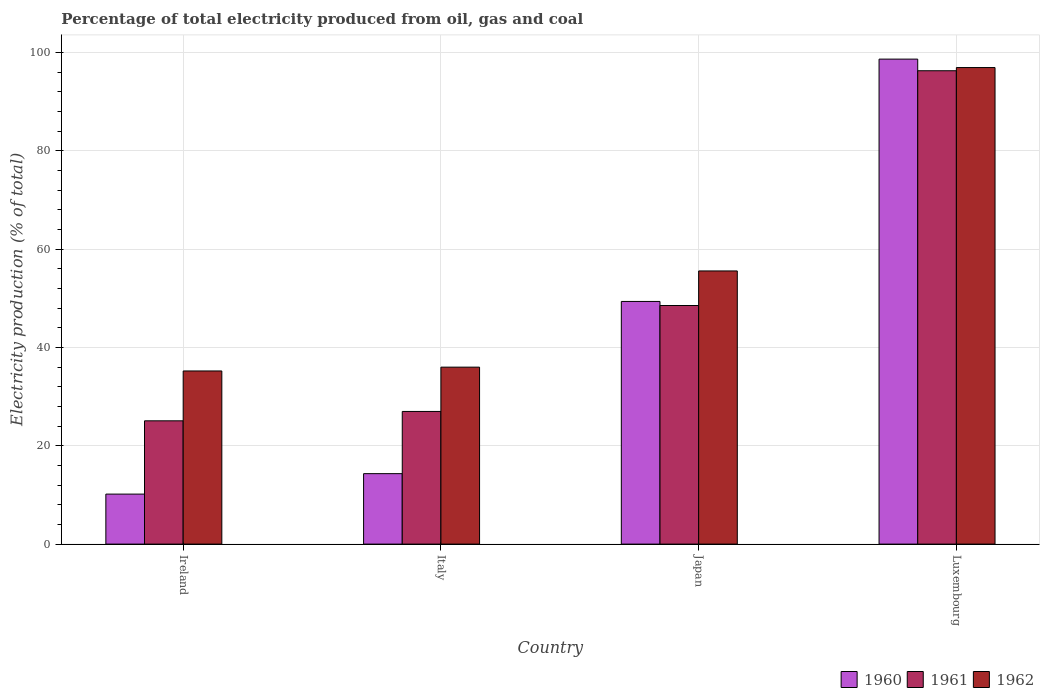How many groups of bars are there?
Offer a terse response. 4. Are the number of bars per tick equal to the number of legend labels?
Your answer should be very brief. Yes. How many bars are there on the 4th tick from the left?
Offer a terse response. 3. How many bars are there on the 1st tick from the right?
Keep it short and to the point. 3. What is the electricity production in in 1961 in Ireland?
Provide a succinct answer. 25.07. Across all countries, what is the maximum electricity production in in 1961?
Provide a succinct answer. 96.27. Across all countries, what is the minimum electricity production in in 1960?
Your answer should be very brief. 10.17. In which country was the electricity production in in 1962 maximum?
Ensure brevity in your answer.  Luxembourg. In which country was the electricity production in in 1962 minimum?
Ensure brevity in your answer.  Ireland. What is the total electricity production in in 1960 in the graph?
Provide a succinct answer. 172.48. What is the difference between the electricity production in in 1961 in Italy and that in Japan?
Provide a short and direct response. -21.55. What is the difference between the electricity production in in 1961 in Luxembourg and the electricity production in in 1960 in Ireland?
Ensure brevity in your answer.  86.1. What is the average electricity production in in 1962 per country?
Your response must be concise. 55.92. What is the difference between the electricity production in of/in 1960 and electricity production in of/in 1962 in Luxembourg?
Provide a succinct answer. 1.72. What is the ratio of the electricity production in in 1961 in Ireland to that in Italy?
Your response must be concise. 0.93. Is the difference between the electricity production in in 1960 in Japan and Luxembourg greater than the difference between the electricity production in in 1962 in Japan and Luxembourg?
Give a very brief answer. No. What is the difference between the highest and the second highest electricity production in in 1961?
Ensure brevity in your answer.  47.75. What is the difference between the highest and the lowest electricity production in in 1960?
Keep it short and to the point. 88.47. What does the 2nd bar from the right in Japan represents?
Provide a succinct answer. 1961. Is it the case that in every country, the sum of the electricity production in in 1962 and electricity production in in 1960 is greater than the electricity production in in 1961?
Provide a succinct answer. Yes. How many countries are there in the graph?
Ensure brevity in your answer.  4. Does the graph contain grids?
Provide a short and direct response. Yes. How many legend labels are there?
Ensure brevity in your answer.  3. What is the title of the graph?
Your response must be concise. Percentage of total electricity produced from oil, gas and coal. What is the label or title of the Y-axis?
Your response must be concise. Electricity production (% of total). What is the Electricity production (% of total) in 1960 in Ireland?
Your answer should be very brief. 10.17. What is the Electricity production (% of total) in 1961 in Ireland?
Your answer should be very brief. 25.07. What is the Electricity production (% of total) of 1962 in Ireland?
Offer a terse response. 35.21. What is the Electricity production (% of total) of 1960 in Italy?
Keep it short and to the point. 14.33. What is the Electricity production (% of total) of 1961 in Italy?
Keep it short and to the point. 26.98. What is the Electricity production (% of total) in 1962 in Italy?
Keep it short and to the point. 35.99. What is the Electricity production (% of total) of 1960 in Japan?
Make the answer very short. 49.35. What is the Electricity production (% of total) of 1961 in Japan?
Make the answer very short. 48.52. What is the Electricity production (% of total) of 1962 in Japan?
Provide a short and direct response. 55.56. What is the Electricity production (% of total) in 1960 in Luxembourg?
Provide a short and direct response. 98.63. What is the Electricity production (% of total) of 1961 in Luxembourg?
Your answer should be very brief. 96.27. What is the Electricity production (% of total) of 1962 in Luxembourg?
Offer a very short reply. 96.92. Across all countries, what is the maximum Electricity production (% of total) of 1960?
Keep it short and to the point. 98.63. Across all countries, what is the maximum Electricity production (% of total) in 1961?
Your response must be concise. 96.27. Across all countries, what is the maximum Electricity production (% of total) of 1962?
Provide a succinct answer. 96.92. Across all countries, what is the minimum Electricity production (% of total) of 1960?
Offer a terse response. 10.17. Across all countries, what is the minimum Electricity production (% of total) of 1961?
Keep it short and to the point. 25.07. Across all countries, what is the minimum Electricity production (% of total) in 1962?
Ensure brevity in your answer.  35.21. What is the total Electricity production (% of total) in 1960 in the graph?
Give a very brief answer. 172.48. What is the total Electricity production (% of total) in 1961 in the graph?
Ensure brevity in your answer.  196.84. What is the total Electricity production (% of total) in 1962 in the graph?
Offer a very short reply. 223.67. What is the difference between the Electricity production (% of total) in 1960 in Ireland and that in Italy?
Provide a succinct answer. -4.16. What is the difference between the Electricity production (% of total) in 1961 in Ireland and that in Italy?
Offer a very short reply. -1.91. What is the difference between the Electricity production (% of total) in 1962 in Ireland and that in Italy?
Ensure brevity in your answer.  -0.78. What is the difference between the Electricity production (% of total) in 1960 in Ireland and that in Japan?
Keep it short and to the point. -39.18. What is the difference between the Electricity production (% of total) of 1961 in Ireland and that in Japan?
Ensure brevity in your answer.  -23.45. What is the difference between the Electricity production (% of total) in 1962 in Ireland and that in Japan?
Provide a succinct answer. -20.34. What is the difference between the Electricity production (% of total) in 1960 in Ireland and that in Luxembourg?
Offer a very short reply. -88.47. What is the difference between the Electricity production (% of total) of 1961 in Ireland and that in Luxembourg?
Provide a short and direct response. -71.2. What is the difference between the Electricity production (% of total) in 1962 in Ireland and that in Luxembourg?
Your answer should be compact. -61.71. What is the difference between the Electricity production (% of total) in 1960 in Italy and that in Japan?
Make the answer very short. -35.02. What is the difference between the Electricity production (% of total) of 1961 in Italy and that in Japan?
Your answer should be very brief. -21.55. What is the difference between the Electricity production (% of total) in 1962 in Italy and that in Japan?
Provide a succinct answer. -19.57. What is the difference between the Electricity production (% of total) of 1960 in Italy and that in Luxembourg?
Provide a short and direct response. -84.31. What is the difference between the Electricity production (% of total) in 1961 in Italy and that in Luxembourg?
Your answer should be compact. -69.29. What is the difference between the Electricity production (% of total) of 1962 in Italy and that in Luxembourg?
Your response must be concise. -60.93. What is the difference between the Electricity production (% of total) in 1960 in Japan and that in Luxembourg?
Give a very brief answer. -49.28. What is the difference between the Electricity production (% of total) of 1961 in Japan and that in Luxembourg?
Keep it short and to the point. -47.75. What is the difference between the Electricity production (% of total) in 1962 in Japan and that in Luxembourg?
Keep it short and to the point. -41.36. What is the difference between the Electricity production (% of total) of 1960 in Ireland and the Electricity production (% of total) of 1961 in Italy?
Provide a succinct answer. -16.81. What is the difference between the Electricity production (% of total) of 1960 in Ireland and the Electricity production (% of total) of 1962 in Italy?
Offer a terse response. -25.82. What is the difference between the Electricity production (% of total) in 1961 in Ireland and the Electricity production (% of total) in 1962 in Italy?
Provide a succinct answer. -10.92. What is the difference between the Electricity production (% of total) of 1960 in Ireland and the Electricity production (% of total) of 1961 in Japan?
Your response must be concise. -38.36. What is the difference between the Electricity production (% of total) of 1960 in Ireland and the Electricity production (% of total) of 1962 in Japan?
Provide a short and direct response. -45.39. What is the difference between the Electricity production (% of total) in 1961 in Ireland and the Electricity production (% of total) in 1962 in Japan?
Ensure brevity in your answer.  -30.48. What is the difference between the Electricity production (% of total) of 1960 in Ireland and the Electricity production (% of total) of 1961 in Luxembourg?
Give a very brief answer. -86.1. What is the difference between the Electricity production (% of total) in 1960 in Ireland and the Electricity production (% of total) in 1962 in Luxembourg?
Ensure brevity in your answer.  -86.75. What is the difference between the Electricity production (% of total) in 1961 in Ireland and the Electricity production (% of total) in 1962 in Luxembourg?
Ensure brevity in your answer.  -71.85. What is the difference between the Electricity production (% of total) in 1960 in Italy and the Electricity production (% of total) in 1961 in Japan?
Offer a terse response. -34.2. What is the difference between the Electricity production (% of total) of 1960 in Italy and the Electricity production (% of total) of 1962 in Japan?
Offer a terse response. -41.23. What is the difference between the Electricity production (% of total) in 1961 in Italy and the Electricity production (% of total) in 1962 in Japan?
Ensure brevity in your answer.  -28.58. What is the difference between the Electricity production (% of total) in 1960 in Italy and the Electricity production (% of total) in 1961 in Luxembourg?
Keep it short and to the point. -81.94. What is the difference between the Electricity production (% of total) in 1960 in Italy and the Electricity production (% of total) in 1962 in Luxembourg?
Keep it short and to the point. -82.59. What is the difference between the Electricity production (% of total) of 1961 in Italy and the Electricity production (% of total) of 1962 in Luxembourg?
Offer a terse response. -69.94. What is the difference between the Electricity production (% of total) of 1960 in Japan and the Electricity production (% of total) of 1961 in Luxembourg?
Make the answer very short. -46.92. What is the difference between the Electricity production (% of total) in 1960 in Japan and the Electricity production (% of total) in 1962 in Luxembourg?
Make the answer very short. -47.57. What is the difference between the Electricity production (% of total) of 1961 in Japan and the Electricity production (% of total) of 1962 in Luxembourg?
Keep it short and to the point. -48.39. What is the average Electricity production (% of total) of 1960 per country?
Give a very brief answer. 43.12. What is the average Electricity production (% of total) of 1961 per country?
Keep it short and to the point. 49.21. What is the average Electricity production (% of total) in 1962 per country?
Offer a terse response. 55.92. What is the difference between the Electricity production (% of total) of 1960 and Electricity production (% of total) of 1961 in Ireland?
Provide a short and direct response. -14.9. What is the difference between the Electricity production (% of total) of 1960 and Electricity production (% of total) of 1962 in Ireland?
Keep it short and to the point. -25.04. What is the difference between the Electricity production (% of total) of 1961 and Electricity production (% of total) of 1962 in Ireland?
Keep it short and to the point. -10.14. What is the difference between the Electricity production (% of total) of 1960 and Electricity production (% of total) of 1961 in Italy?
Keep it short and to the point. -12.65. What is the difference between the Electricity production (% of total) of 1960 and Electricity production (% of total) of 1962 in Italy?
Your answer should be compact. -21.66. What is the difference between the Electricity production (% of total) of 1961 and Electricity production (% of total) of 1962 in Italy?
Offer a very short reply. -9.01. What is the difference between the Electricity production (% of total) in 1960 and Electricity production (% of total) in 1961 in Japan?
Offer a terse response. 0.83. What is the difference between the Electricity production (% of total) of 1960 and Electricity production (% of total) of 1962 in Japan?
Provide a succinct answer. -6.2. What is the difference between the Electricity production (% of total) of 1961 and Electricity production (% of total) of 1962 in Japan?
Make the answer very short. -7.03. What is the difference between the Electricity production (% of total) of 1960 and Electricity production (% of total) of 1961 in Luxembourg?
Make the answer very short. 2.36. What is the difference between the Electricity production (% of total) of 1960 and Electricity production (% of total) of 1962 in Luxembourg?
Provide a succinct answer. 1.72. What is the difference between the Electricity production (% of total) in 1961 and Electricity production (% of total) in 1962 in Luxembourg?
Offer a terse response. -0.65. What is the ratio of the Electricity production (% of total) in 1960 in Ireland to that in Italy?
Offer a terse response. 0.71. What is the ratio of the Electricity production (% of total) of 1961 in Ireland to that in Italy?
Offer a terse response. 0.93. What is the ratio of the Electricity production (% of total) in 1962 in Ireland to that in Italy?
Offer a terse response. 0.98. What is the ratio of the Electricity production (% of total) in 1960 in Ireland to that in Japan?
Provide a short and direct response. 0.21. What is the ratio of the Electricity production (% of total) in 1961 in Ireland to that in Japan?
Provide a succinct answer. 0.52. What is the ratio of the Electricity production (% of total) in 1962 in Ireland to that in Japan?
Ensure brevity in your answer.  0.63. What is the ratio of the Electricity production (% of total) in 1960 in Ireland to that in Luxembourg?
Offer a terse response. 0.1. What is the ratio of the Electricity production (% of total) in 1961 in Ireland to that in Luxembourg?
Keep it short and to the point. 0.26. What is the ratio of the Electricity production (% of total) in 1962 in Ireland to that in Luxembourg?
Provide a short and direct response. 0.36. What is the ratio of the Electricity production (% of total) of 1960 in Italy to that in Japan?
Make the answer very short. 0.29. What is the ratio of the Electricity production (% of total) of 1961 in Italy to that in Japan?
Ensure brevity in your answer.  0.56. What is the ratio of the Electricity production (% of total) of 1962 in Italy to that in Japan?
Offer a terse response. 0.65. What is the ratio of the Electricity production (% of total) in 1960 in Italy to that in Luxembourg?
Your response must be concise. 0.15. What is the ratio of the Electricity production (% of total) in 1961 in Italy to that in Luxembourg?
Your answer should be compact. 0.28. What is the ratio of the Electricity production (% of total) in 1962 in Italy to that in Luxembourg?
Your answer should be very brief. 0.37. What is the ratio of the Electricity production (% of total) of 1960 in Japan to that in Luxembourg?
Your answer should be very brief. 0.5. What is the ratio of the Electricity production (% of total) in 1961 in Japan to that in Luxembourg?
Offer a terse response. 0.5. What is the ratio of the Electricity production (% of total) in 1962 in Japan to that in Luxembourg?
Your answer should be compact. 0.57. What is the difference between the highest and the second highest Electricity production (% of total) of 1960?
Offer a terse response. 49.28. What is the difference between the highest and the second highest Electricity production (% of total) of 1961?
Provide a succinct answer. 47.75. What is the difference between the highest and the second highest Electricity production (% of total) in 1962?
Offer a terse response. 41.36. What is the difference between the highest and the lowest Electricity production (% of total) in 1960?
Give a very brief answer. 88.47. What is the difference between the highest and the lowest Electricity production (% of total) of 1961?
Your answer should be compact. 71.2. What is the difference between the highest and the lowest Electricity production (% of total) in 1962?
Make the answer very short. 61.71. 